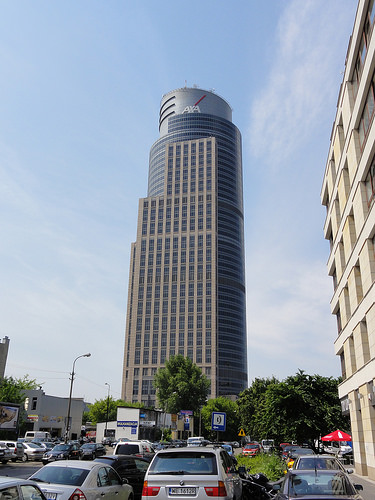<image>
Can you confirm if the buliding is above the tree? Yes. The buliding is positioned above the tree in the vertical space, higher up in the scene. 